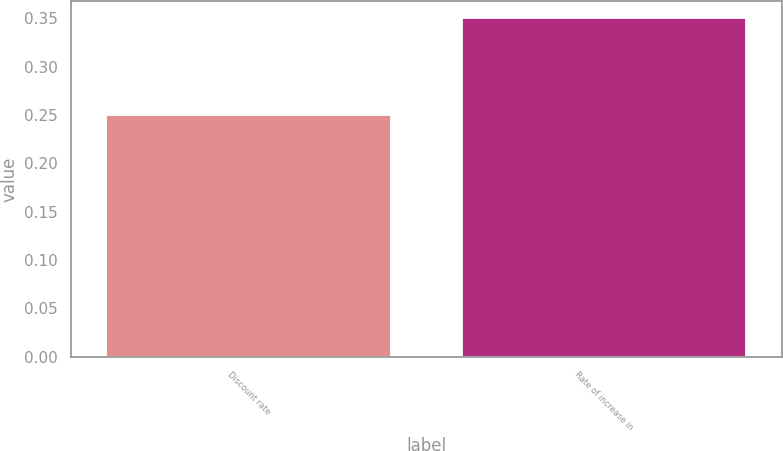Convert chart to OTSL. <chart><loc_0><loc_0><loc_500><loc_500><bar_chart><fcel>Discount rate<fcel>Rate of increase in<nl><fcel>0.25<fcel>0.35<nl></chart> 